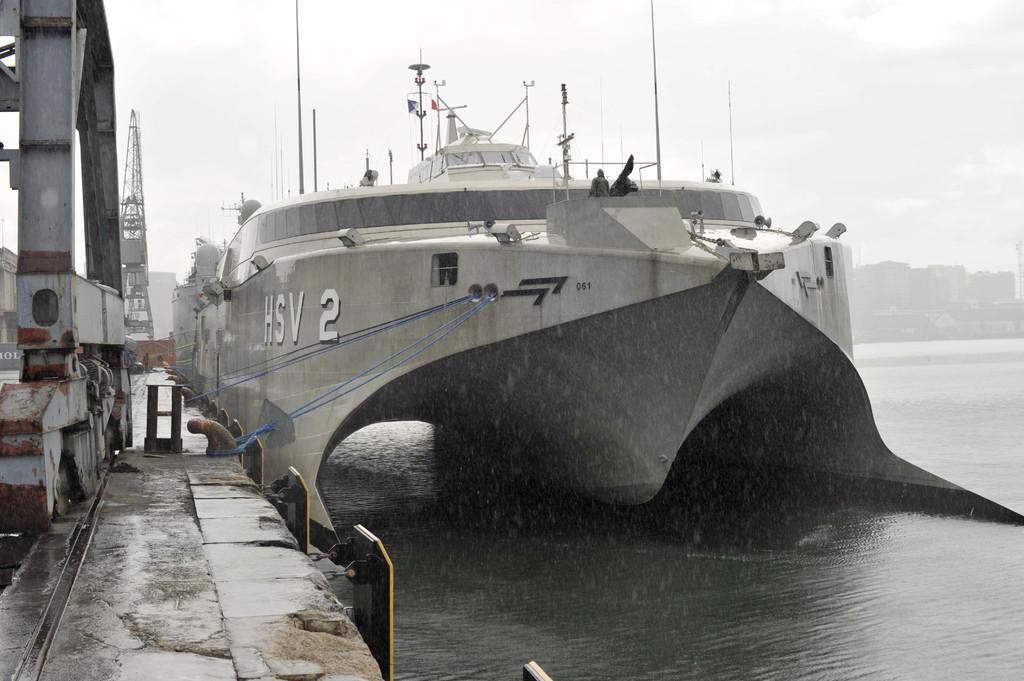What is the main subject of the image? The main subject of the image is a ship in the water. How is the ship secured in the image? The ship is tied with ropes in the image. What is located near the ship? There is a crane beside the ship and metal rods are present near the ship. What can be seen in the background of the image? There are buildings in the background of the image. Can you describe the bee that is buzzing around the ship in the image? There is no bee present in the image; it features a ship in the water with a crane and metal rods nearby. What type of structure is the earth supporting in the image? There is no structure or reference to the earth in the image; it only shows a ship, ropes, a crane, metal rods, and buildings in the background. 